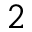Convert formula to latex. <formula><loc_0><loc_0><loc_500><loc_500>^ { 2 }</formula> 